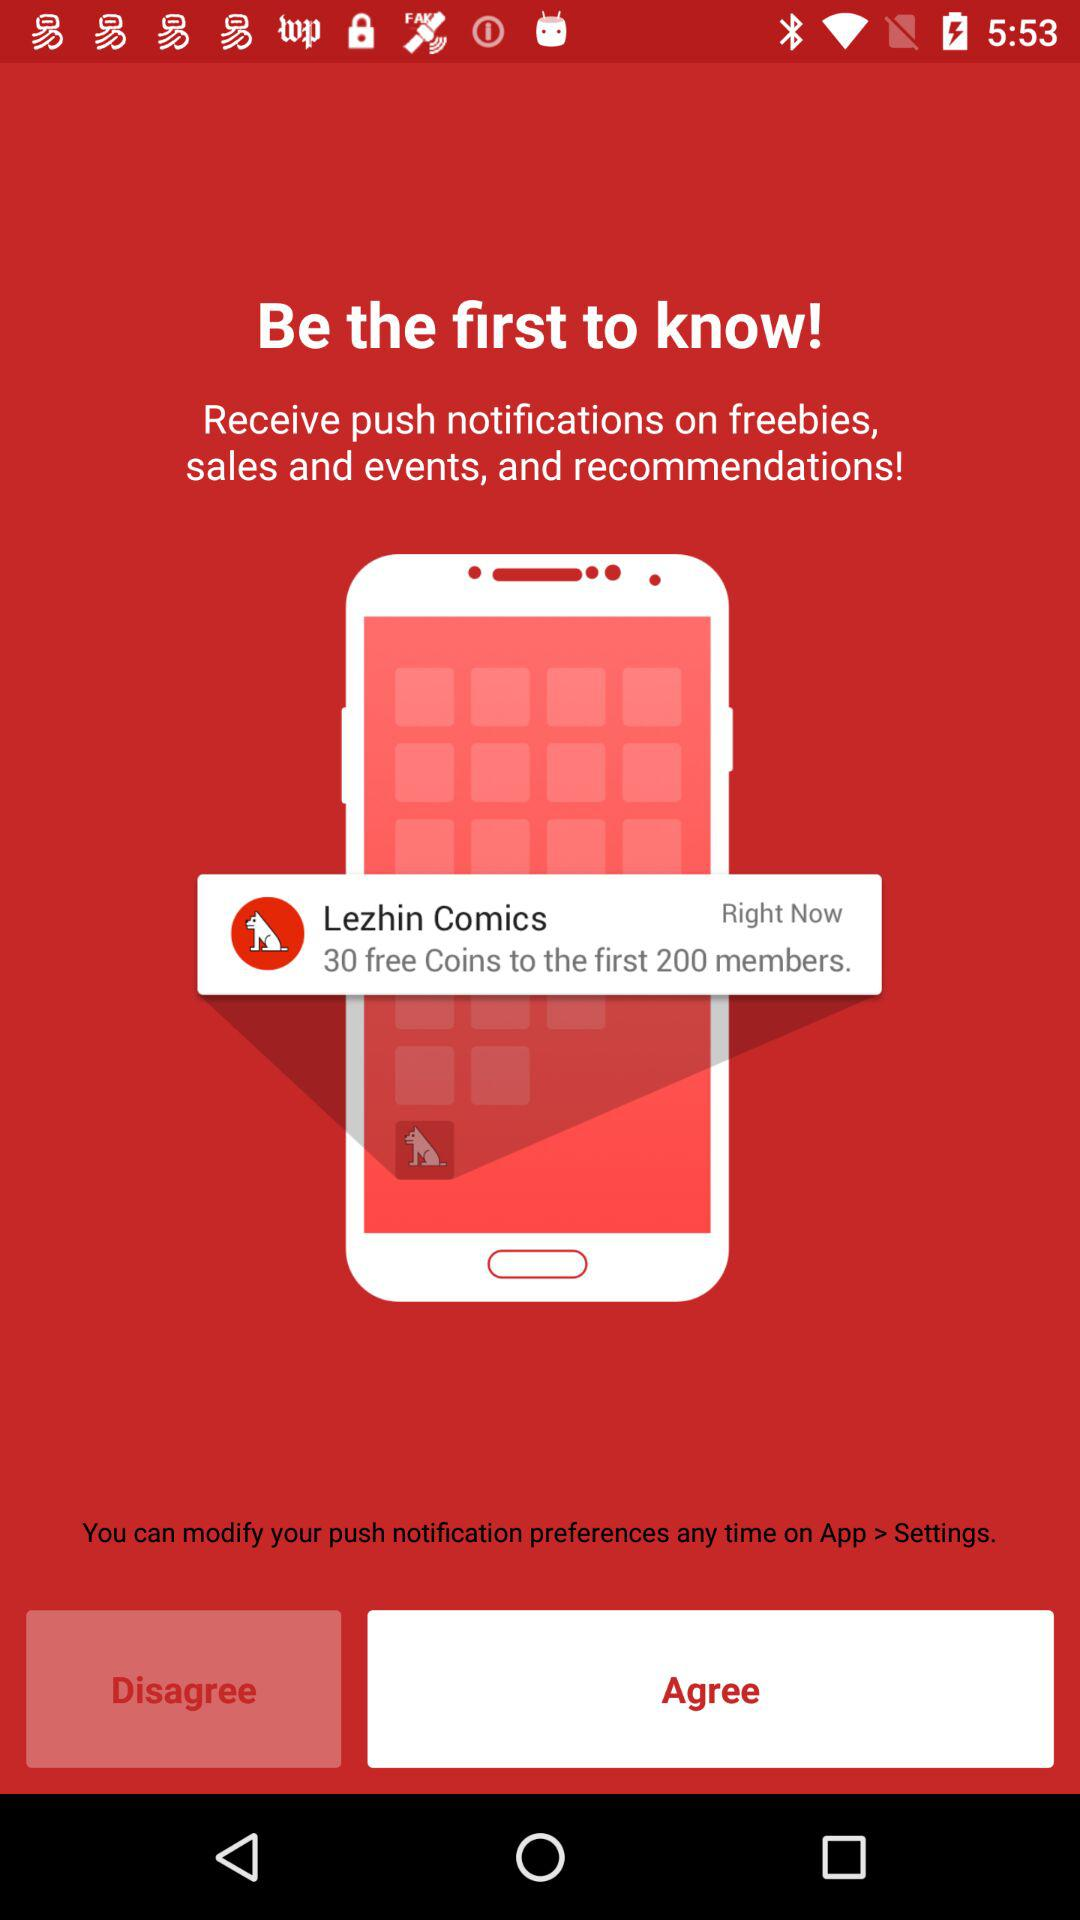How many free coins are there to be won?
Answer the question using a single word or phrase. 30 